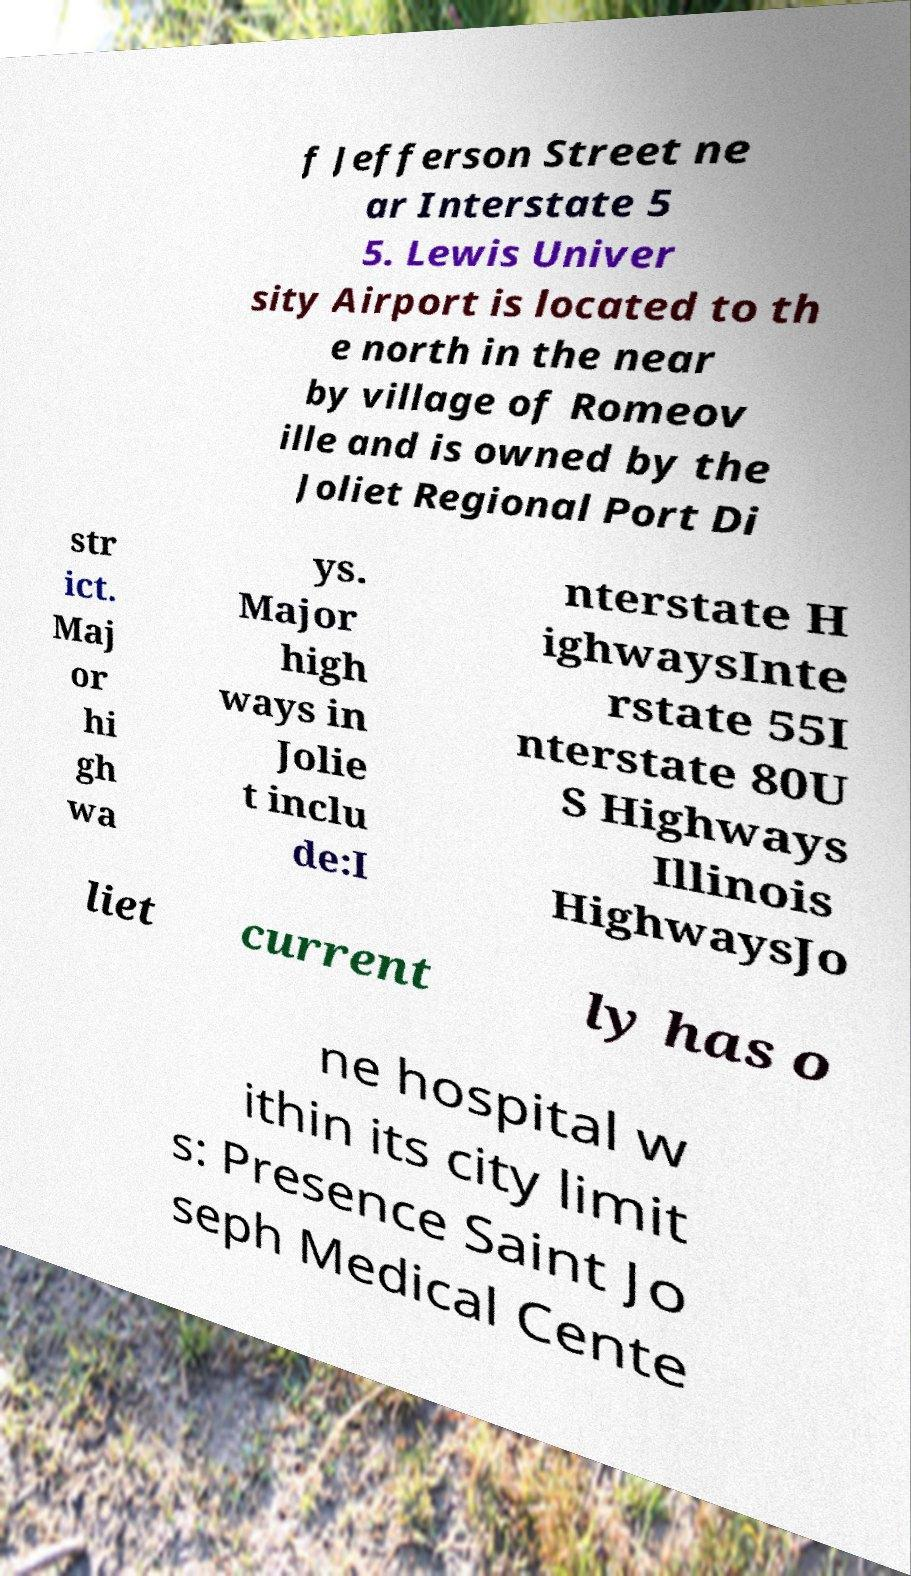Please read and relay the text visible in this image. What does it say? f Jefferson Street ne ar Interstate 5 5. Lewis Univer sity Airport is located to th e north in the near by village of Romeov ille and is owned by the Joliet Regional Port Di str ict. Maj or hi gh wa ys. Major high ways in Jolie t inclu de:I nterstate H ighwaysInte rstate 55I nterstate 80U S Highways Illinois HighwaysJo liet current ly has o ne hospital w ithin its city limit s: Presence Saint Jo seph Medical Cente 